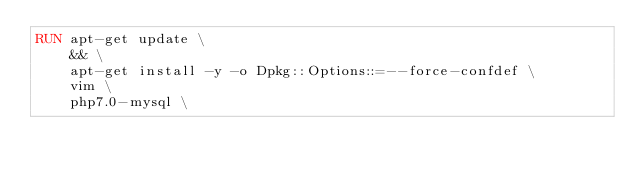Convert code to text. <code><loc_0><loc_0><loc_500><loc_500><_Dockerfile_>RUN apt-get update \
    && \
    apt-get install -y -o Dpkg::Options::=--force-confdef \
    vim \
    php7.0-mysql \</code> 